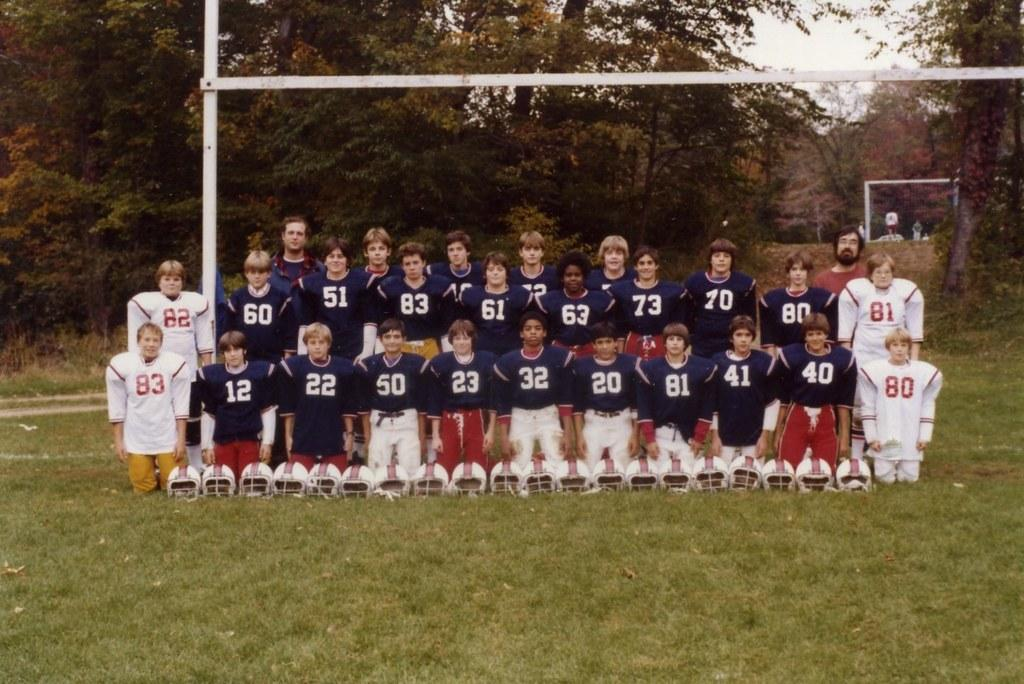<image>
Present a compact description of the photo's key features. A group of athletes posing on the football field, with four in white jerseys marked 80, 81, 82, and 83. 